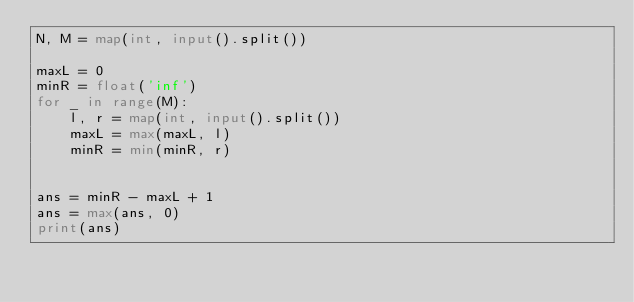<code> <loc_0><loc_0><loc_500><loc_500><_Python_>N, M = map(int, input().split())

maxL = 0
minR = float('inf')
for _ in range(M):
    l, r = map(int, input().split())
    maxL = max(maxL, l)
    minR = min(minR, r)


ans = minR - maxL + 1
ans = max(ans, 0)
print(ans)
</code> 